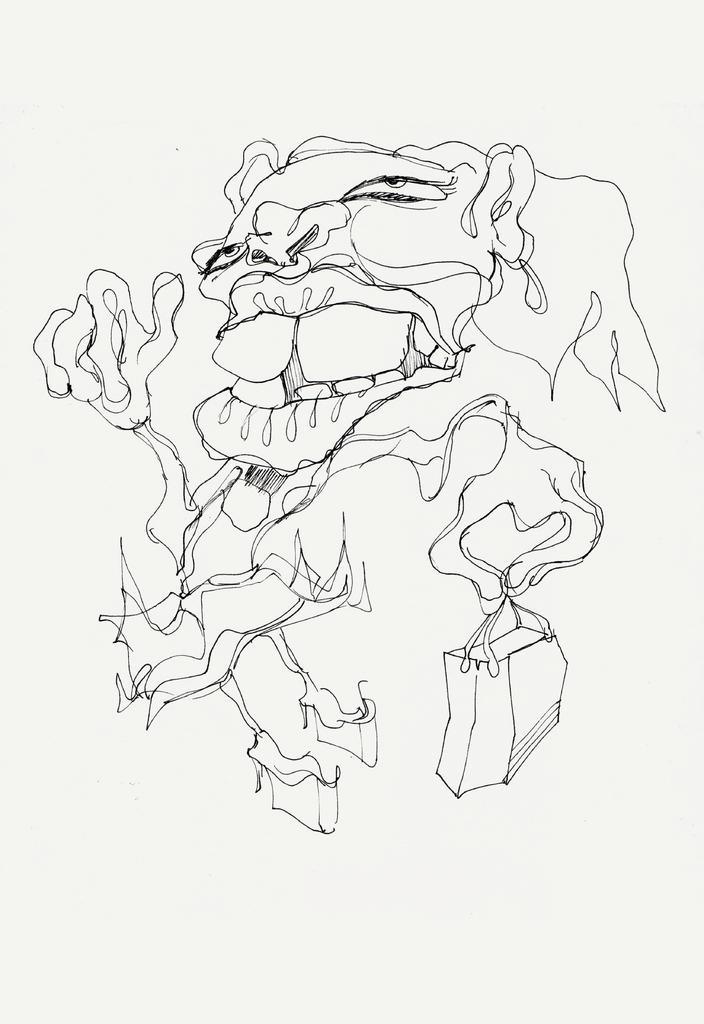Describe this image in one or two sentences. In this image we can see a drawing on the paper. 